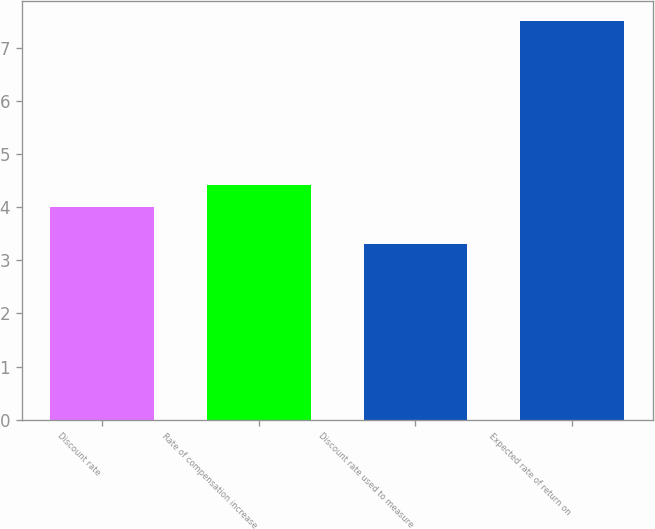Convert chart to OTSL. <chart><loc_0><loc_0><loc_500><loc_500><bar_chart><fcel>Discount rate<fcel>Rate of compensation increase<fcel>Discount rate used to measure<fcel>Expected rate of return on<nl><fcel>4<fcel>4.42<fcel>3.3<fcel>7.5<nl></chart> 